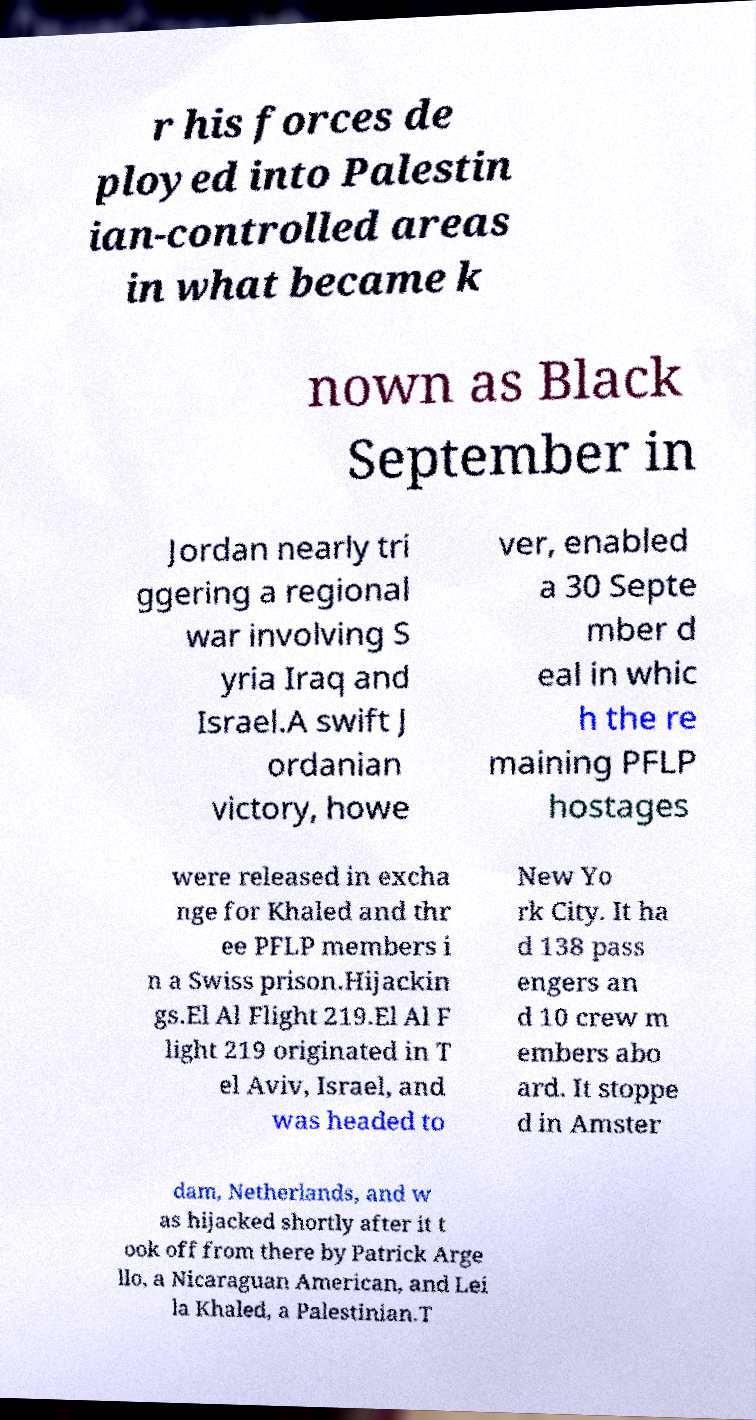Could you extract and type out the text from this image? r his forces de ployed into Palestin ian-controlled areas in what became k nown as Black September in Jordan nearly tri ggering a regional war involving S yria Iraq and Israel.A swift J ordanian victory, howe ver, enabled a 30 Septe mber d eal in whic h the re maining PFLP hostages were released in excha nge for Khaled and thr ee PFLP members i n a Swiss prison.Hijackin gs.El Al Flight 219.El Al F light 219 originated in T el Aviv, Israel, and was headed to New Yo rk City. It ha d 138 pass engers an d 10 crew m embers abo ard. It stoppe d in Amster dam, Netherlands, and w as hijacked shortly after it t ook off from there by Patrick Arge llo, a Nicaraguan American, and Lei la Khaled, a Palestinian.T 